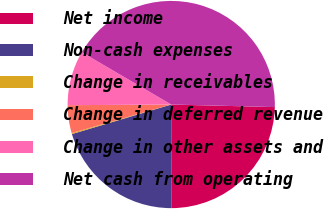<chart> <loc_0><loc_0><loc_500><loc_500><pie_chart><fcel>Net income<fcel>Non-cash expenses<fcel>Change in receivables<fcel>Change in deferred revenue<fcel>Change in other assets and<fcel>Net cash from operating<nl><fcel>24.59%<fcel>20.41%<fcel>0.16%<fcel>4.34%<fcel>8.52%<fcel>41.97%<nl></chart> 